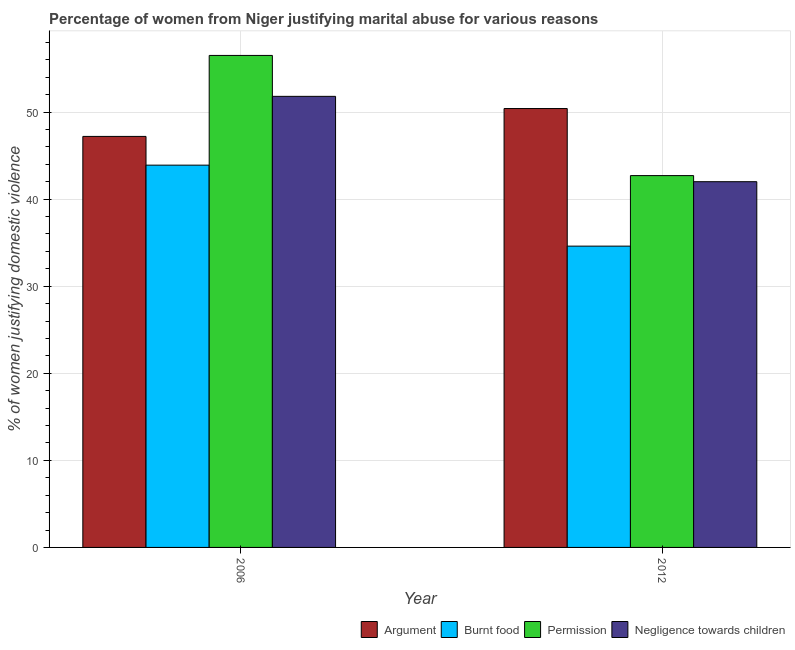What is the percentage of women justifying abuse in the case of an argument in 2012?
Provide a short and direct response. 50.4. Across all years, what is the maximum percentage of women justifying abuse in the case of an argument?
Make the answer very short. 50.4. Across all years, what is the minimum percentage of women justifying abuse for burning food?
Offer a very short reply. 34.6. In which year was the percentage of women justifying abuse in the case of an argument maximum?
Offer a terse response. 2012. In which year was the percentage of women justifying abuse for going without permission minimum?
Provide a succinct answer. 2012. What is the total percentage of women justifying abuse for burning food in the graph?
Keep it short and to the point. 78.5. What is the difference between the percentage of women justifying abuse for showing negligence towards children in 2006 and that in 2012?
Your response must be concise. 9.8. What is the difference between the percentage of women justifying abuse in the case of an argument in 2012 and the percentage of women justifying abuse for going without permission in 2006?
Your answer should be very brief. 3.2. What is the average percentage of women justifying abuse for going without permission per year?
Offer a terse response. 49.6. In the year 2012, what is the difference between the percentage of women justifying abuse in the case of an argument and percentage of women justifying abuse for going without permission?
Ensure brevity in your answer.  0. What is the ratio of the percentage of women justifying abuse for burning food in 2006 to that in 2012?
Offer a terse response. 1.27. Is it the case that in every year, the sum of the percentage of women justifying abuse for burning food and percentage of women justifying abuse in the case of an argument is greater than the sum of percentage of women justifying abuse for going without permission and percentage of women justifying abuse for showing negligence towards children?
Make the answer very short. Yes. What does the 1st bar from the left in 2006 represents?
Give a very brief answer. Argument. What does the 1st bar from the right in 2012 represents?
Make the answer very short. Negligence towards children. How many bars are there?
Give a very brief answer. 8. How many years are there in the graph?
Provide a short and direct response. 2. What is the difference between two consecutive major ticks on the Y-axis?
Provide a succinct answer. 10. Are the values on the major ticks of Y-axis written in scientific E-notation?
Offer a very short reply. No. Where does the legend appear in the graph?
Your answer should be compact. Bottom right. How many legend labels are there?
Ensure brevity in your answer.  4. How are the legend labels stacked?
Your answer should be very brief. Horizontal. What is the title of the graph?
Provide a short and direct response. Percentage of women from Niger justifying marital abuse for various reasons. Does "Greece" appear as one of the legend labels in the graph?
Offer a very short reply. No. What is the label or title of the Y-axis?
Make the answer very short. % of women justifying domestic violence. What is the % of women justifying domestic violence of Argument in 2006?
Your answer should be very brief. 47.2. What is the % of women justifying domestic violence in Burnt food in 2006?
Keep it short and to the point. 43.9. What is the % of women justifying domestic violence of Permission in 2006?
Your response must be concise. 56.5. What is the % of women justifying domestic violence in Negligence towards children in 2006?
Your answer should be compact. 51.8. What is the % of women justifying domestic violence of Argument in 2012?
Keep it short and to the point. 50.4. What is the % of women justifying domestic violence of Burnt food in 2012?
Ensure brevity in your answer.  34.6. What is the % of women justifying domestic violence of Permission in 2012?
Offer a very short reply. 42.7. Across all years, what is the maximum % of women justifying domestic violence in Argument?
Provide a succinct answer. 50.4. Across all years, what is the maximum % of women justifying domestic violence in Burnt food?
Your answer should be compact. 43.9. Across all years, what is the maximum % of women justifying domestic violence of Permission?
Your response must be concise. 56.5. Across all years, what is the maximum % of women justifying domestic violence in Negligence towards children?
Offer a terse response. 51.8. Across all years, what is the minimum % of women justifying domestic violence of Argument?
Ensure brevity in your answer.  47.2. Across all years, what is the minimum % of women justifying domestic violence of Burnt food?
Your answer should be compact. 34.6. Across all years, what is the minimum % of women justifying domestic violence of Permission?
Provide a succinct answer. 42.7. What is the total % of women justifying domestic violence of Argument in the graph?
Provide a succinct answer. 97.6. What is the total % of women justifying domestic violence of Burnt food in the graph?
Offer a terse response. 78.5. What is the total % of women justifying domestic violence of Permission in the graph?
Provide a short and direct response. 99.2. What is the total % of women justifying domestic violence in Negligence towards children in the graph?
Your response must be concise. 93.8. What is the difference between the % of women justifying domestic violence in Argument in 2006 and that in 2012?
Give a very brief answer. -3.2. What is the difference between the % of women justifying domestic violence in Negligence towards children in 2006 and that in 2012?
Provide a short and direct response. 9.8. What is the difference between the % of women justifying domestic violence of Argument in 2006 and the % of women justifying domestic violence of Burnt food in 2012?
Offer a very short reply. 12.6. What is the difference between the % of women justifying domestic violence in Burnt food in 2006 and the % of women justifying domestic violence in Negligence towards children in 2012?
Your response must be concise. 1.9. What is the difference between the % of women justifying domestic violence in Permission in 2006 and the % of women justifying domestic violence in Negligence towards children in 2012?
Offer a very short reply. 14.5. What is the average % of women justifying domestic violence in Argument per year?
Keep it short and to the point. 48.8. What is the average % of women justifying domestic violence in Burnt food per year?
Your response must be concise. 39.25. What is the average % of women justifying domestic violence of Permission per year?
Your answer should be compact. 49.6. What is the average % of women justifying domestic violence of Negligence towards children per year?
Provide a short and direct response. 46.9. In the year 2006, what is the difference between the % of women justifying domestic violence in Argument and % of women justifying domestic violence in Burnt food?
Offer a terse response. 3.3. In the year 2006, what is the difference between the % of women justifying domestic violence in Argument and % of women justifying domestic violence in Permission?
Your answer should be compact. -9.3. In the year 2006, what is the difference between the % of women justifying domestic violence of Burnt food and % of women justifying domestic violence of Negligence towards children?
Provide a short and direct response. -7.9. In the year 2012, what is the difference between the % of women justifying domestic violence in Argument and % of women justifying domestic violence in Negligence towards children?
Provide a succinct answer. 8.4. In the year 2012, what is the difference between the % of women justifying domestic violence in Burnt food and % of women justifying domestic violence in Negligence towards children?
Ensure brevity in your answer.  -7.4. What is the ratio of the % of women justifying domestic violence of Argument in 2006 to that in 2012?
Give a very brief answer. 0.94. What is the ratio of the % of women justifying domestic violence of Burnt food in 2006 to that in 2012?
Keep it short and to the point. 1.27. What is the ratio of the % of women justifying domestic violence in Permission in 2006 to that in 2012?
Provide a short and direct response. 1.32. What is the ratio of the % of women justifying domestic violence of Negligence towards children in 2006 to that in 2012?
Offer a very short reply. 1.23. What is the difference between the highest and the second highest % of women justifying domestic violence of Argument?
Provide a short and direct response. 3.2. What is the difference between the highest and the second highest % of women justifying domestic violence of Burnt food?
Provide a short and direct response. 9.3. What is the difference between the highest and the second highest % of women justifying domestic violence of Permission?
Your answer should be compact. 13.8. What is the difference between the highest and the lowest % of women justifying domestic violence in Argument?
Your response must be concise. 3.2. What is the difference between the highest and the lowest % of women justifying domestic violence in Burnt food?
Provide a succinct answer. 9.3. 